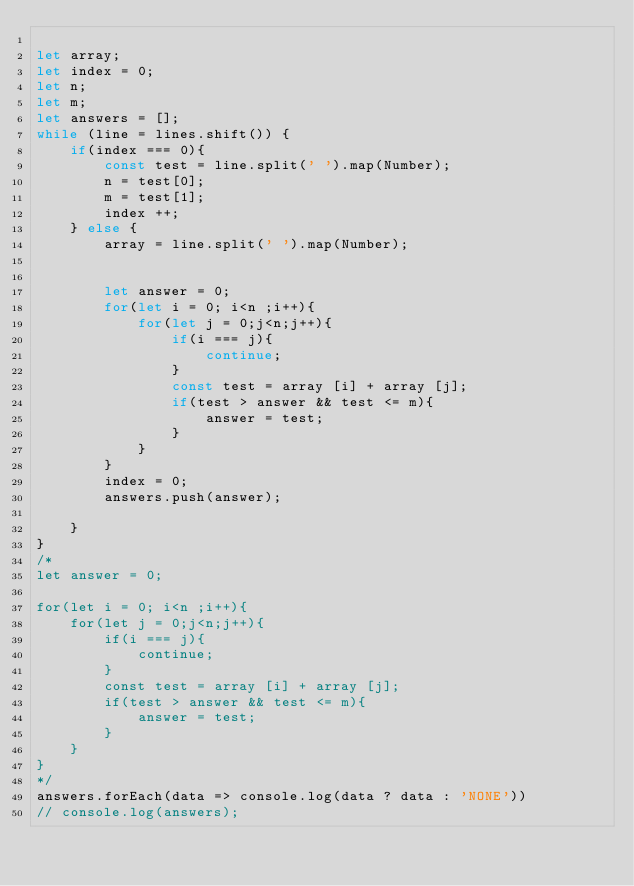Convert code to text. <code><loc_0><loc_0><loc_500><loc_500><_JavaScript_>
let array;
let index = 0;
let n;
let m;
let answers = [];
while (line = lines.shift()) {
    if(index === 0){
        const test = line.split(' ').map(Number);
        n = test[0];
        m = test[1];
        index ++;
    } else {
        array = line.split(' ').map(Number);


        let answer = 0;
        for(let i = 0; i<n ;i++){
            for(let j = 0;j<n;j++){
                if(i === j){
                    continue;
                }
                const test = array [i] + array [j];
                if(test > answer && test <= m){
                    answer = test;
                }
            }
        }
        index = 0;
        answers.push(answer);

    }
}
/*
let answer = 0;

for(let i = 0; i<n ;i++){
    for(let j = 0;j<n;j++){
        if(i === j){
            continue;
        }
        const test = array [i] + array [j];
        if(test > answer && test <= m){
            answer = test;
        }
    }
}
*/
answers.forEach(data => console.log(data ? data : 'NONE'))
// console.log(answers);
</code> 